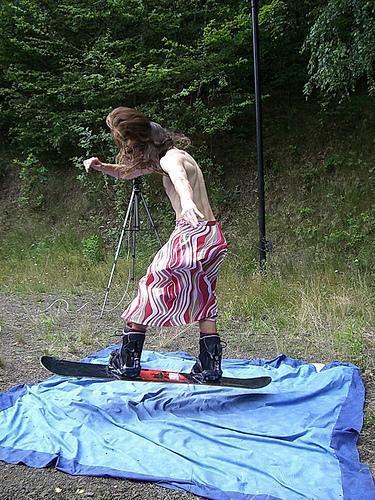How many people are in the picture?
Give a very brief answer. 1. 